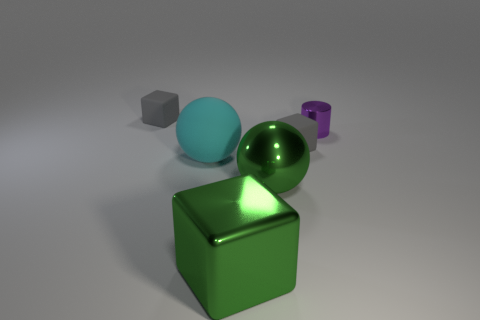Add 2 large brown shiny spheres. How many objects exist? 8 Subtract all cylinders. How many objects are left? 5 Add 5 metal balls. How many metal balls are left? 6 Add 2 big green blocks. How many big green blocks exist? 3 Subtract 1 green cubes. How many objects are left? 5 Subtract all cylinders. Subtract all red objects. How many objects are left? 5 